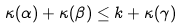<formula> <loc_0><loc_0><loc_500><loc_500>\kappa ( \alpha ) + \kappa ( \beta ) \leq k + \kappa ( \gamma )</formula> 